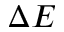<formula> <loc_0><loc_0><loc_500><loc_500>\Delta E</formula> 